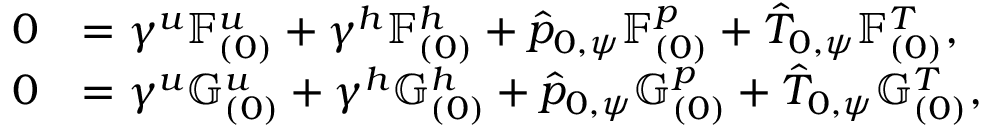<formula> <loc_0><loc_0><loc_500><loc_500>\begin{array} { r l } { 0 } & { = \gamma ^ { u } \mathbb { F } _ { ( 0 ) } ^ { u } + \gamma ^ { h } \mathbb { F } _ { ( 0 ) } ^ { h } + \hat { p } _ { 0 , \psi } \mathbb { F } _ { ( 0 ) } ^ { p } + \hat { T } _ { 0 , \psi } \mathbb { F } _ { ( 0 ) } ^ { T } , } \\ { 0 } & { = \gamma ^ { u } \mathbb { G } _ { ( 0 ) } ^ { u } + \gamma ^ { h } \mathbb { G } _ { ( 0 ) } ^ { h } + \hat { p } _ { 0 , \psi } \mathbb { G } _ { ( 0 ) } ^ { p } + \hat { T } _ { 0 , \psi } \mathbb { G } _ { ( 0 ) } ^ { T } , } \end{array}</formula> 